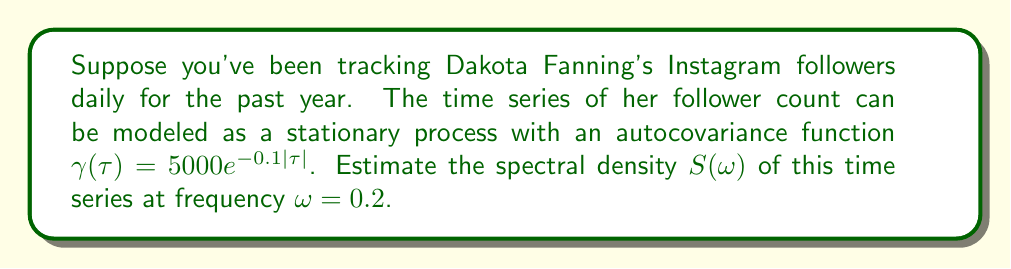Solve this math problem. To estimate the spectral density, we'll follow these steps:

1) For a stationary process, the spectral density $S(\omega)$ is the Fourier transform of the autocovariance function $\gamma(\tau)$:

   $$S(\omega) = \frac{1}{2\pi} \int_{-\infty}^{\infty} \gamma(\tau) e^{-i\omega\tau} d\tau$$

2) Given $\gamma(\tau) = 5000e^{-0.1|\tau|}$, we can split the integral:

   $$S(\omega) = \frac{5000}{2\pi} \left(\int_{0}^{\infty} e^{-0.1\tau} e^{-i\omega\tau} d\tau + \int_{-\infty}^{0} e^{0.1\tau} e^{-i\omega\tau} d\tau\right)$$

3) Solve the first integral:
   
   $$\int_{0}^{\infty} e^{-0.1\tau} e^{-i\omega\tau} d\tau = \int_{0}^{\infty} e^{-(0.1+i\omega)\tau} d\tau = \frac{1}{0.1+i\omega}$$

4) Solve the second integral:
   
   $$\int_{-\infty}^{0} e^{0.1\tau} e^{-i\omega\tau} d\tau = \int_{-\infty}^{0} e^{(0.1-i\omega)\tau} d\tau = \frac{1}{0.1-i\omega}$$

5) Combine the results:

   $$S(\omega) = \frac{5000}{2\pi} \left(\frac{1}{0.1+i\omega} + \frac{1}{0.1-i\omega}\right)$$

6) Simplify:

   $$S(\omega) = \frac{5000}{2\pi} \cdot \frac{0.2}{0.01+\omega^2}$$

7) Evaluate at $\omega = 0.2$:

   $$S(0.2) = \frac{5000}{2\pi} \cdot \frac{0.2}{0.01+0.2^2} \approx 397.89$$
Answer: $397.89$ 